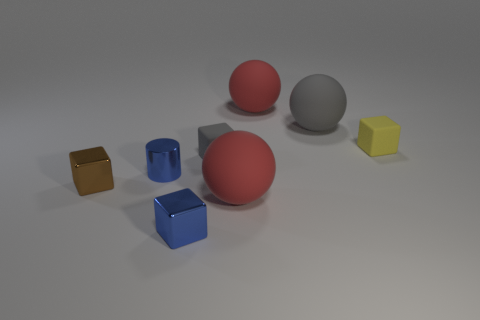What number of other things are the same material as the yellow cube?
Offer a very short reply. 4. What color is the other metallic thing that is the same shape as the small brown metal object?
Ensure brevity in your answer.  Blue. Do the blue metal object that is in front of the brown thing and the gray cube have the same size?
Your response must be concise. Yes. Is the number of brown objects that are left of the tiny brown shiny thing less than the number of brown metal cubes?
Provide a short and direct response. Yes. Is there anything else that is the same size as the blue cylinder?
Provide a succinct answer. Yes. How big is the blue shiny object that is behind the red rubber ball in front of the tiny gray thing?
Provide a succinct answer. Small. Are there any other things that have the same shape as the small yellow matte thing?
Give a very brief answer. Yes. Is the number of gray spheres less than the number of big red cylinders?
Provide a succinct answer. No. There is a big thing that is to the left of the gray sphere and behind the small metal cylinder; what is it made of?
Keep it short and to the point. Rubber. There is a big sphere in front of the small blue cylinder; is there a big gray rubber object that is left of it?
Your response must be concise. No. 